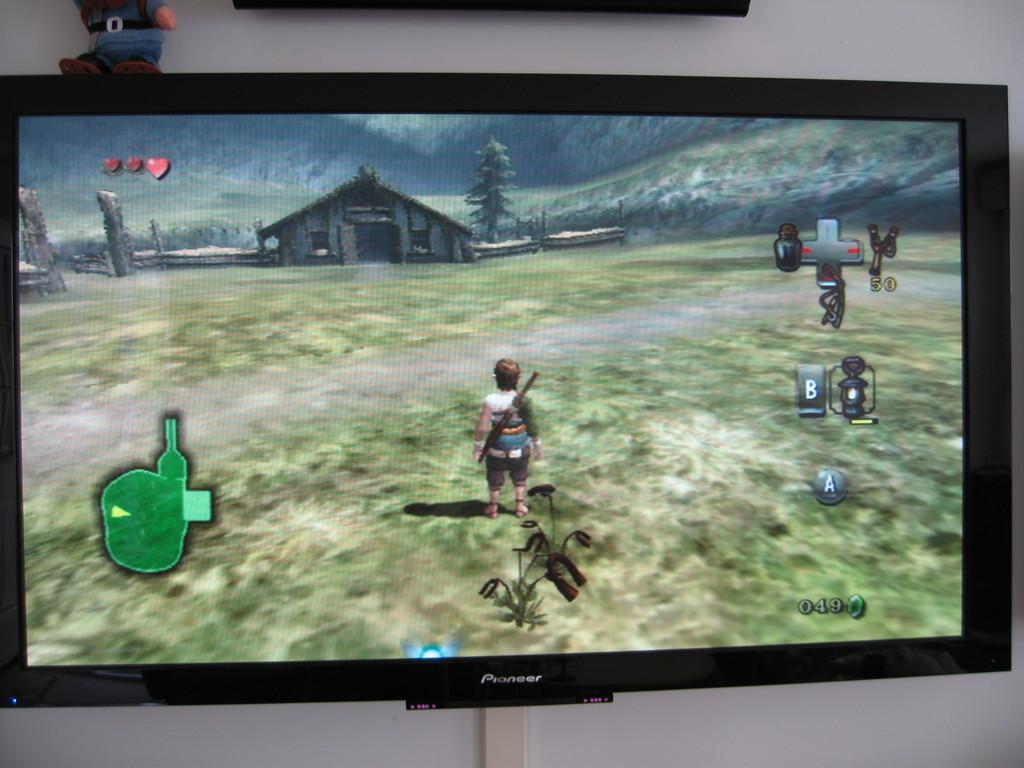What brand is the tv?
Give a very brief answer. Pioneer. 